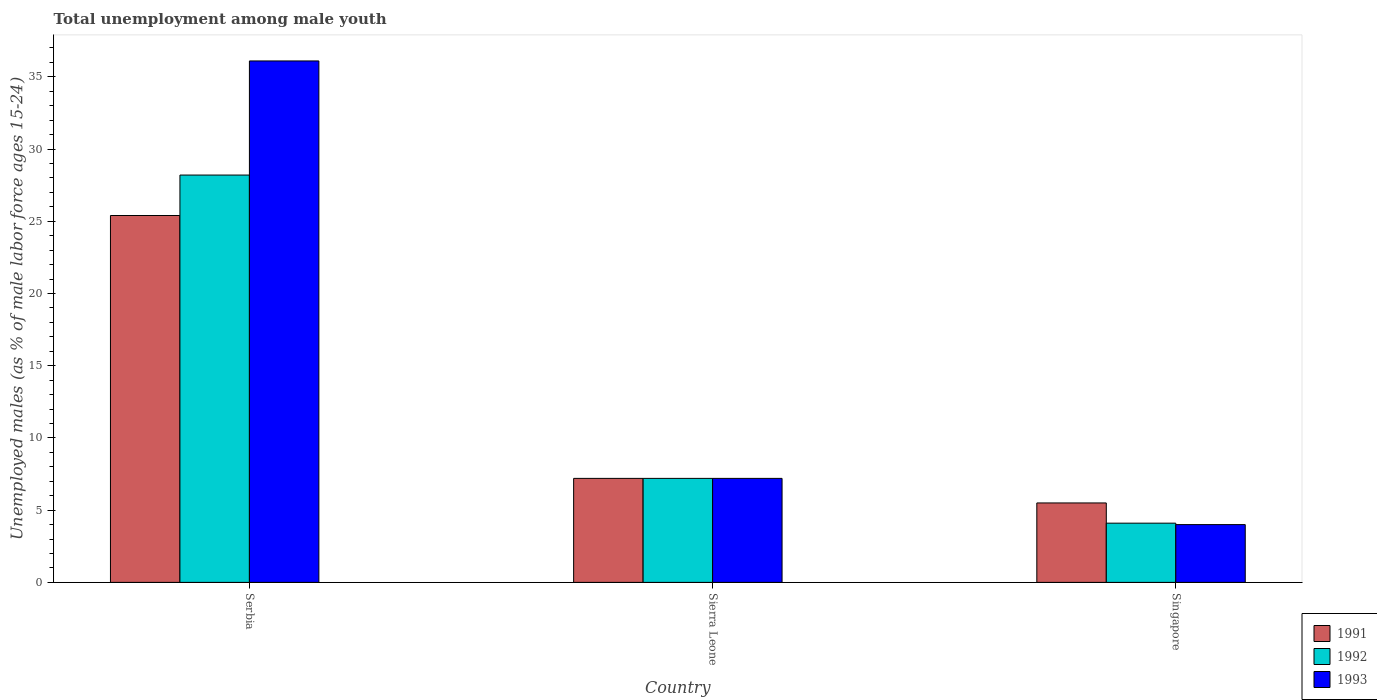How many bars are there on the 2nd tick from the right?
Offer a terse response. 3. What is the label of the 1st group of bars from the left?
Keep it short and to the point. Serbia. What is the percentage of unemployed males in in 1991 in Serbia?
Give a very brief answer. 25.4. Across all countries, what is the maximum percentage of unemployed males in in 1992?
Your answer should be very brief. 28.2. In which country was the percentage of unemployed males in in 1992 maximum?
Give a very brief answer. Serbia. In which country was the percentage of unemployed males in in 1992 minimum?
Offer a terse response. Singapore. What is the total percentage of unemployed males in in 1992 in the graph?
Keep it short and to the point. 39.5. What is the difference between the percentage of unemployed males in in 1992 in Sierra Leone and that in Singapore?
Your answer should be very brief. 3.1. What is the difference between the percentage of unemployed males in in 1991 in Sierra Leone and the percentage of unemployed males in in 1993 in Singapore?
Ensure brevity in your answer.  3.2. What is the average percentage of unemployed males in in 1991 per country?
Offer a terse response. 12.7. What is the difference between the percentage of unemployed males in of/in 1991 and percentage of unemployed males in of/in 1992 in Singapore?
Provide a short and direct response. 1.4. What is the ratio of the percentage of unemployed males in in 1991 in Sierra Leone to that in Singapore?
Give a very brief answer. 1.31. Is the percentage of unemployed males in in 1991 in Sierra Leone less than that in Singapore?
Give a very brief answer. No. What is the difference between the highest and the second highest percentage of unemployed males in in 1991?
Offer a very short reply. 19.9. What is the difference between the highest and the lowest percentage of unemployed males in in 1993?
Your answer should be very brief. 32.1. In how many countries, is the percentage of unemployed males in in 1993 greater than the average percentage of unemployed males in in 1993 taken over all countries?
Keep it short and to the point. 1. What does the 1st bar from the right in Serbia represents?
Your answer should be compact. 1993. How many bars are there?
Your answer should be compact. 9. What is the difference between two consecutive major ticks on the Y-axis?
Keep it short and to the point. 5. Are the values on the major ticks of Y-axis written in scientific E-notation?
Your answer should be very brief. No. Does the graph contain any zero values?
Provide a succinct answer. No. Where does the legend appear in the graph?
Provide a short and direct response. Bottom right. How many legend labels are there?
Offer a terse response. 3. What is the title of the graph?
Ensure brevity in your answer.  Total unemployment among male youth. What is the label or title of the X-axis?
Offer a terse response. Country. What is the label or title of the Y-axis?
Ensure brevity in your answer.  Unemployed males (as % of male labor force ages 15-24). What is the Unemployed males (as % of male labor force ages 15-24) in 1991 in Serbia?
Offer a very short reply. 25.4. What is the Unemployed males (as % of male labor force ages 15-24) of 1992 in Serbia?
Your answer should be very brief. 28.2. What is the Unemployed males (as % of male labor force ages 15-24) of 1993 in Serbia?
Your answer should be very brief. 36.1. What is the Unemployed males (as % of male labor force ages 15-24) of 1991 in Sierra Leone?
Provide a succinct answer. 7.2. What is the Unemployed males (as % of male labor force ages 15-24) of 1992 in Sierra Leone?
Your response must be concise. 7.2. What is the Unemployed males (as % of male labor force ages 15-24) in 1993 in Sierra Leone?
Your response must be concise. 7.2. What is the Unemployed males (as % of male labor force ages 15-24) of 1991 in Singapore?
Keep it short and to the point. 5.5. What is the Unemployed males (as % of male labor force ages 15-24) in 1992 in Singapore?
Offer a terse response. 4.1. Across all countries, what is the maximum Unemployed males (as % of male labor force ages 15-24) of 1991?
Give a very brief answer. 25.4. Across all countries, what is the maximum Unemployed males (as % of male labor force ages 15-24) of 1992?
Keep it short and to the point. 28.2. Across all countries, what is the maximum Unemployed males (as % of male labor force ages 15-24) of 1993?
Provide a short and direct response. 36.1. Across all countries, what is the minimum Unemployed males (as % of male labor force ages 15-24) in 1992?
Keep it short and to the point. 4.1. Across all countries, what is the minimum Unemployed males (as % of male labor force ages 15-24) of 1993?
Offer a terse response. 4. What is the total Unemployed males (as % of male labor force ages 15-24) in 1991 in the graph?
Offer a very short reply. 38.1. What is the total Unemployed males (as % of male labor force ages 15-24) in 1992 in the graph?
Keep it short and to the point. 39.5. What is the total Unemployed males (as % of male labor force ages 15-24) in 1993 in the graph?
Make the answer very short. 47.3. What is the difference between the Unemployed males (as % of male labor force ages 15-24) of 1992 in Serbia and that in Sierra Leone?
Provide a short and direct response. 21. What is the difference between the Unemployed males (as % of male labor force ages 15-24) in 1993 in Serbia and that in Sierra Leone?
Provide a short and direct response. 28.9. What is the difference between the Unemployed males (as % of male labor force ages 15-24) of 1991 in Serbia and that in Singapore?
Your answer should be compact. 19.9. What is the difference between the Unemployed males (as % of male labor force ages 15-24) of 1992 in Serbia and that in Singapore?
Keep it short and to the point. 24.1. What is the difference between the Unemployed males (as % of male labor force ages 15-24) in 1993 in Serbia and that in Singapore?
Provide a succinct answer. 32.1. What is the difference between the Unemployed males (as % of male labor force ages 15-24) in 1992 in Sierra Leone and that in Singapore?
Ensure brevity in your answer.  3.1. What is the difference between the Unemployed males (as % of male labor force ages 15-24) in 1993 in Sierra Leone and that in Singapore?
Your answer should be very brief. 3.2. What is the difference between the Unemployed males (as % of male labor force ages 15-24) in 1992 in Serbia and the Unemployed males (as % of male labor force ages 15-24) in 1993 in Sierra Leone?
Your answer should be compact. 21. What is the difference between the Unemployed males (as % of male labor force ages 15-24) in 1991 in Serbia and the Unemployed males (as % of male labor force ages 15-24) in 1992 in Singapore?
Provide a succinct answer. 21.3. What is the difference between the Unemployed males (as % of male labor force ages 15-24) in 1991 in Serbia and the Unemployed males (as % of male labor force ages 15-24) in 1993 in Singapore?
Ensure brevity in your answer.  21.4. What is the difference between the Unemployed males (as % of male labor force ages 15-24) in 1992 in Serbia and the Unemployed males (as % of male labor force ages 15-24) in 1993 in Singapore?
Your response must be concise. 24.2. What is the difference between the Unemployed males (as % of male labor force ages 15-24) of 1991 in Sierra Leone and the Unemployed males (as % of male labor force ages 15-24) of 1992 in Singapore?
Ensure brevity in your answer.  3.1. What is the difference between the Unemployed males (as % of male labor force ages 15-24) in 1991 in Sierra Leone and the Unemployed males (as % of male labor force ages 15-24) in 1993 in Singapore?
Make the answer very short. 3.2. What is the difference between the Unemployed males (as % of male labor force ages 15-24) in 1992 in Sierra Leone and the Unemployed males (as % of male labor force ages 15-24) in 1993 in Singapore?
Keep it short and to the point. 3.2. What is the average Unemployed males (as % of male labor force ages 15-24) of 1992 per country?
Ensure brevity in your answer.  13.17. What is the average Unemployed males (as % of male labor force ages 15-24) of 1993 per country?
Keep it short and to the point. 15.77. What is the difference between the Unemployed males (as % of male labor force ages 15-24) in 1991 and Unemployed males (as % of male labor force ages 15-24) in 1992 in Serbia?
Keep it short and to the point. -2.8. What is the difference between the Unemployed males (as % of male labor force ages 15-24) of 1991 and Unemployed males (as % of male labor force ages 15-24) of 1993 in Serbia?
Your answer should be very brief. -10.7. What is the difference between the Unemployed males (as % of male labor force ages 15-24) in 1992 and Unemployed males (as % of male labor force ages 15-24) in 1993 in Serbia?
Your answer should be very brief. -7.9. What is the difference between the Unemployed males (as % of male labor force ages 15-24) of 1991 and Unemployed males (as % of male labor force ages 15-24) of 1992 in Sierra Leone?
Give a very brief answer. 0. What is the difference between the Unemployed males (as % of male labor force ages 15-24) in 1992 and Unemployed males (as % of male labor force ages 15-24) in 1993 in Sierra Leone?
Give a very brief answer. 0. What is the difference between the Unemployed males (as % of male labor force ages 15-24) in 1991 and Unemployed males (as % of male labor force ages 15-24) in 1992 in Singapore?
Your response must be concise. 1.4. What is the ratio of the Unemployed males (as % of male labor force ages 15-24) of 1991 in Serbia to that in Sierra Leone?
Keep it short and to the point. 3.53. What is the ratio of the Unemployed males (as % of male labor force ages 15-24) in 1992 in Serbia to that in Sierra Leone?
Give a very brief answer. 3.92. What is the ratio of the Unemployed males (as % of male labor force ages 15-24) of 1993 in Serbia to that in Sierra Leone?
Your answer should be very brief. 5.01. What is the ratio of the Unemployed males (as % of male labor force ages 15-24) in 1991 in Serbia to that in Singapore?
Your response must be concise. 4.62. What is the ratio of the Unemployed males (as % of male labor force ages 15-24) in 1992 in Serbia to that in Singapore?
Give a very brief answer. 6.88. What is the ratio of the Unemployed males (as % of male labor force ages 15-24) of 1993 in Serbia to that in Singapore?
Your response must be concise. 9.03. What is the ratio of the Unemployed males (as % of male labor force ages 15-24) in 1991 in Sierra Leone to that in Singapore?
Your answer should be very brief. 1.31. What is the ratio of the Unemployed males (as % of male labor force ages 15-24) in 1992 in Sierra Leone to that in Singapore?
Provide a short and direct response. 1.76. What is the difference between the highest and the second highest Unemployed males (as % of male labor force ages 15-24) of 1991?
Make the answer very short. 18.2. What is the difference between the highest and the second highest Unemployed males (as % of male labor force ages 15-24) in 1992?
Offer a terse response. 21. What is the difference between the highest and the second highest Unemployed males (as % of male labor force ages 15-24) in 1993?
Your response must be concise. 28.9. What is the difference between the highest and the lowest Unemployed males (as % of male labor force ages 15-24) of 1991?
Your response must be concise. 19.9. What is the difference between the highest and the lowest Unemployed males (as % of male labor force ages 15-24) in 1992?
Your answer should be very brief. 24.1. What is the difference between the highest and the lowest Unemployed males (as % of male labor force ages 15-24) in 1993?
Give a very brief answer. 32.1. 